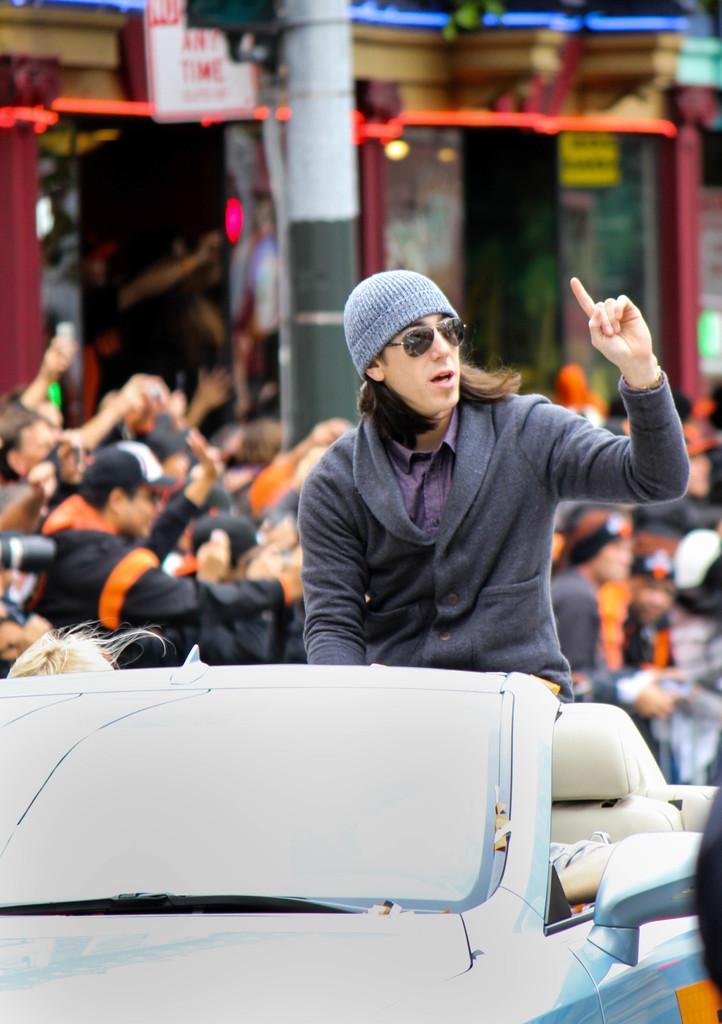What are the people in the image doing? The people in the image are standing. Can you describe the position of one person in the image? There is a person sitting in a car. What object can be seen in the image that is vertical and stationary? There is a pole in the image. What type of support does the fireman provide in the image? There is no fireman present in the image, so no support can be provided by a fireman. 